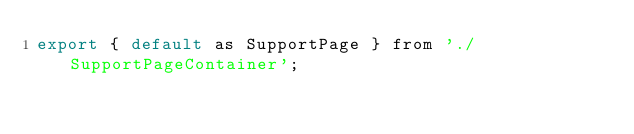<code> <loc_0><loc_0><loc_500><loc_500><_JavaScript_>export { default as SupportPage } from './SupportPageContainer';
</code> 